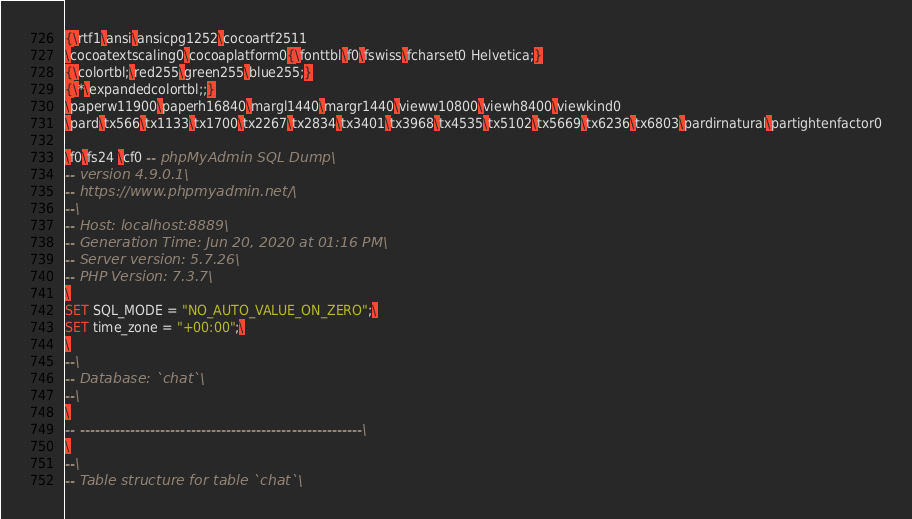Convert code to text. <code><loc_0><loc_0><loc_500><loc_500><_SQL_>{\rtf1\ansi\ansicpg1252\cocoartf2511
\cocoatextscaling0\cocoaplatform0{\fonttbl\f0\fswiss\fcharset0 Helvetica;}
{\colortbl;\red255\green255\blue255;}
{\*\expandedcolortbl;;}
\paperw11900\paperh16840\margl1440\margr1440\vieww10800\viewh8400\viewkind0
\pard\tx566\tx1133\tx1700\tx2267\tx2834\tx3401\tx3968\tx4535\tx5102\tx5669\tx6236\tx6803\pardirnatural\partightenfactor0

\f0\fs24 \cf0 -- phpMyAdmin SQL Dump\
-- version 4.9.0.1\
-- https://www.phpmyadmin.net/\
--\
-- Host: localhost:8889\
-- Generation Time: Jun 20, 2020 at 01:16 PM\
-- Server version: 5.7.26\
-- PHP Version: 7.3.7\
\
SET SQL_MODE = "NO_AUTO_VALUE_ON_ZERO";\
SET time_zone = "+00:00";\
\
--\
-- Database: `chat`\
--\
\
-- --------------------------------------------------------\
\
--\
-- Table structure for table `chat`\</code> 